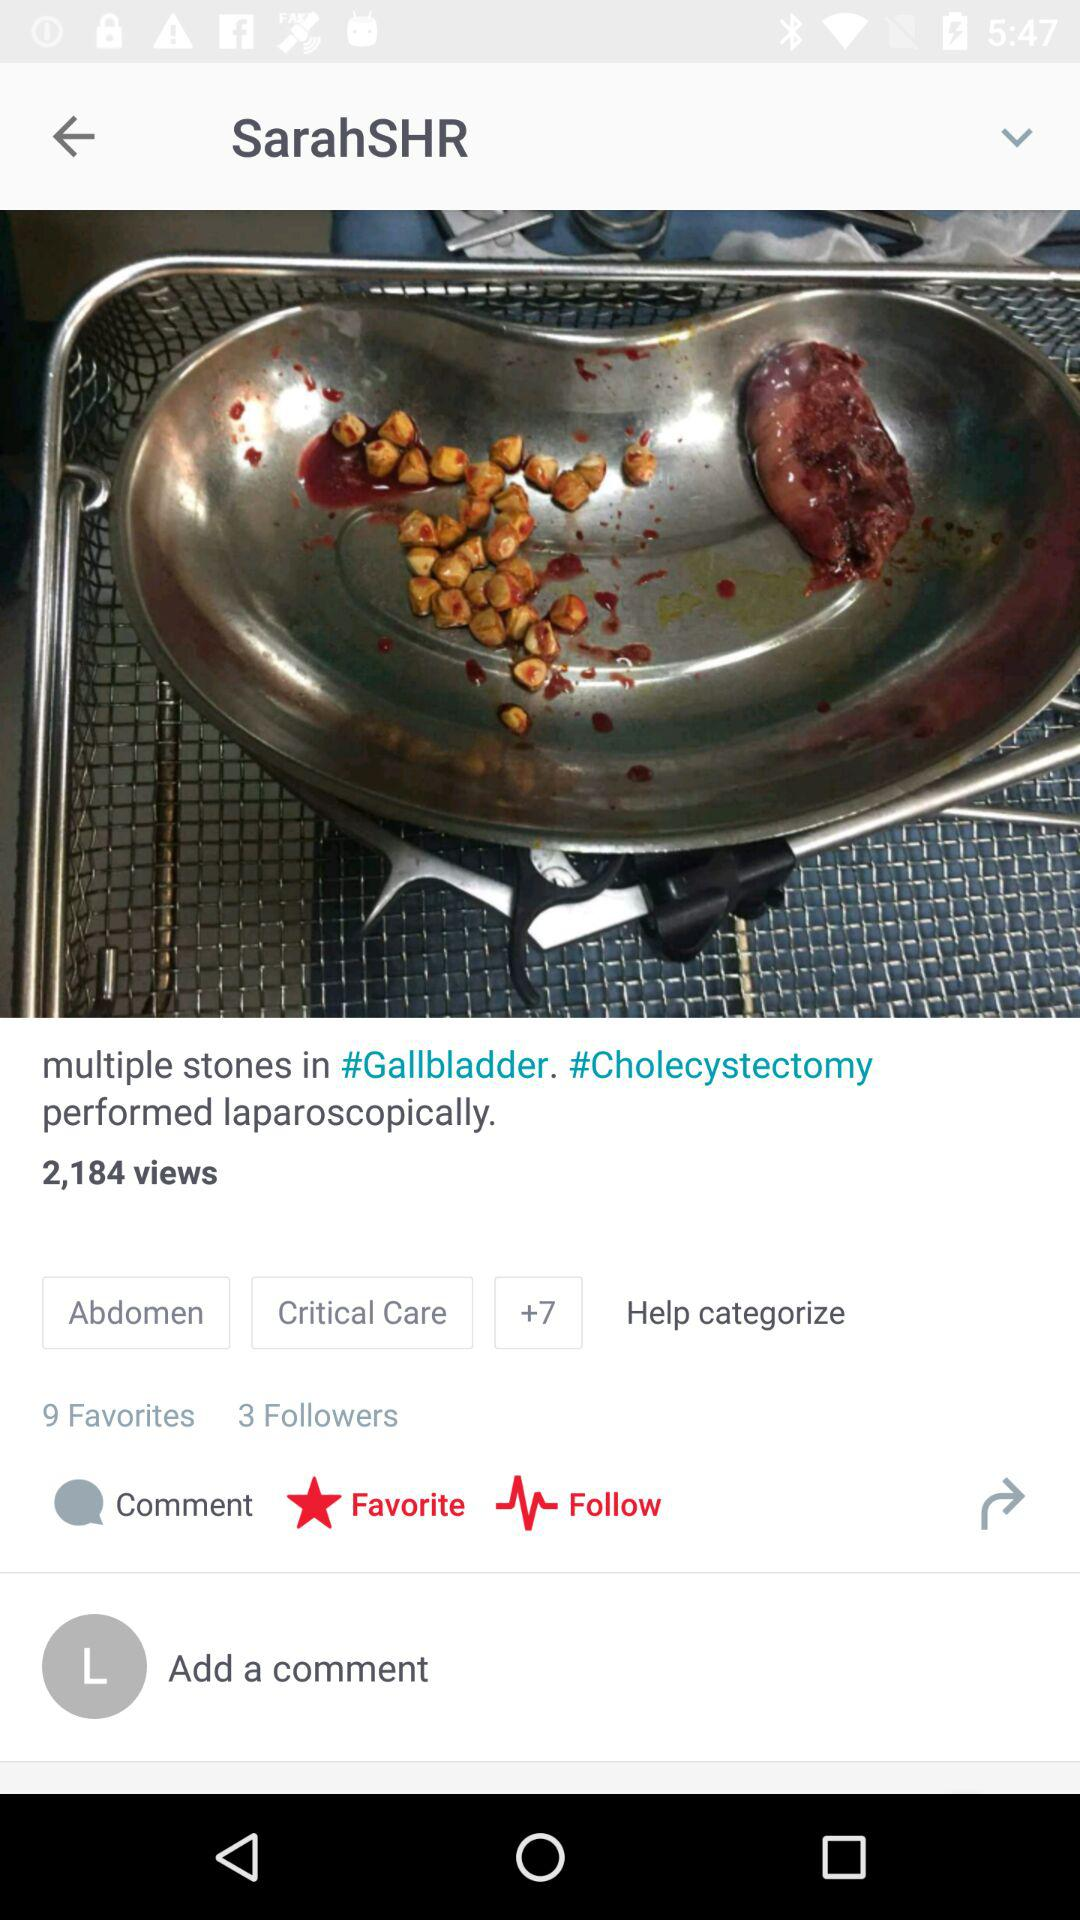What is the username? The username is "lauralee". 